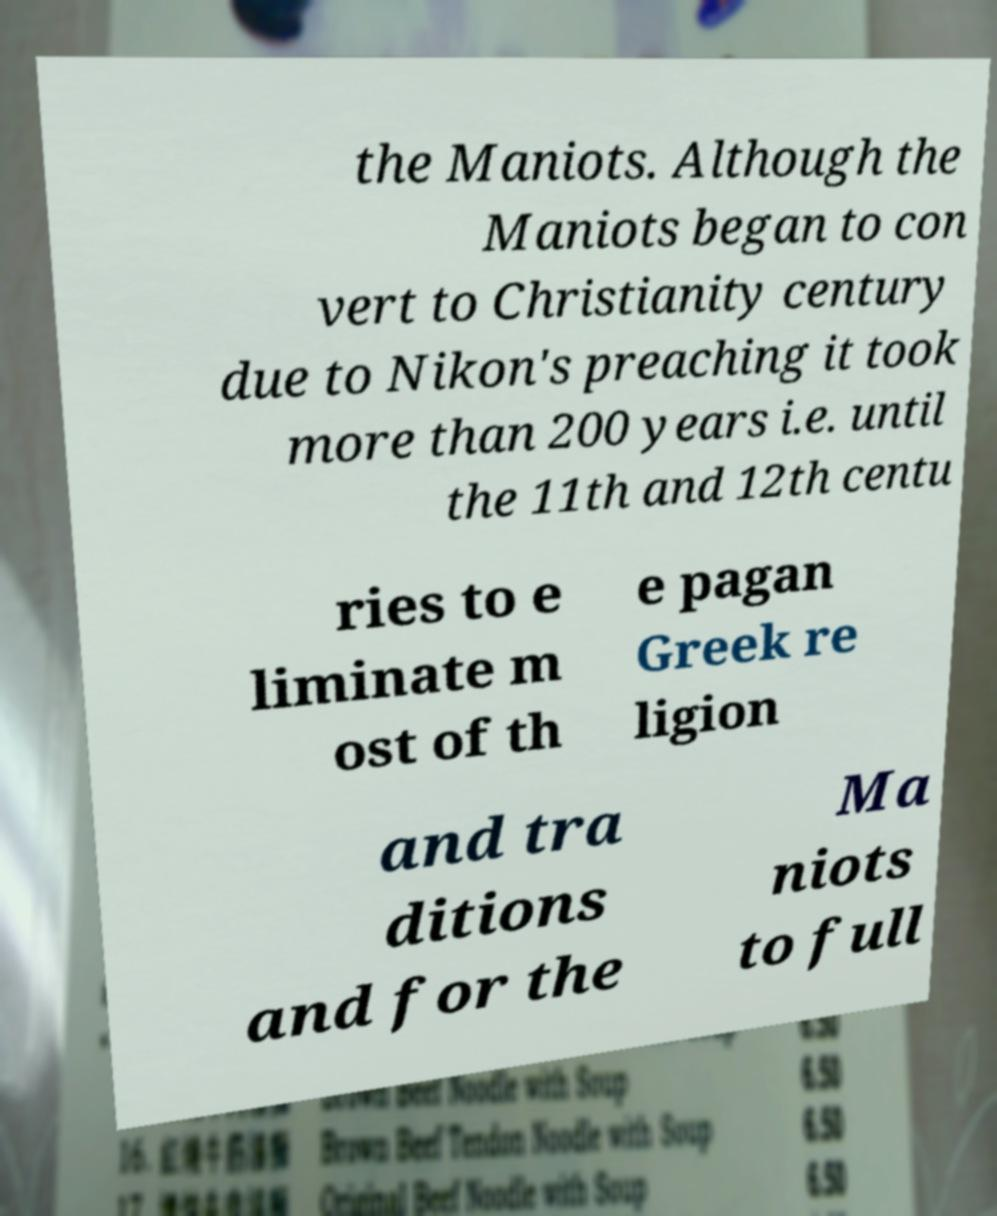For documentation purposes, I need the text within this image transcribed. Could you provide that? the Maniots. Although the Maniots began to con vert to Christianity century due to Nikon's preaching it took more than 200 years i.e. until the 11th and 12th centu ries to e liminate m ost of th e pagan Greek re ligion and tra ditions and for the Ma niots to full 